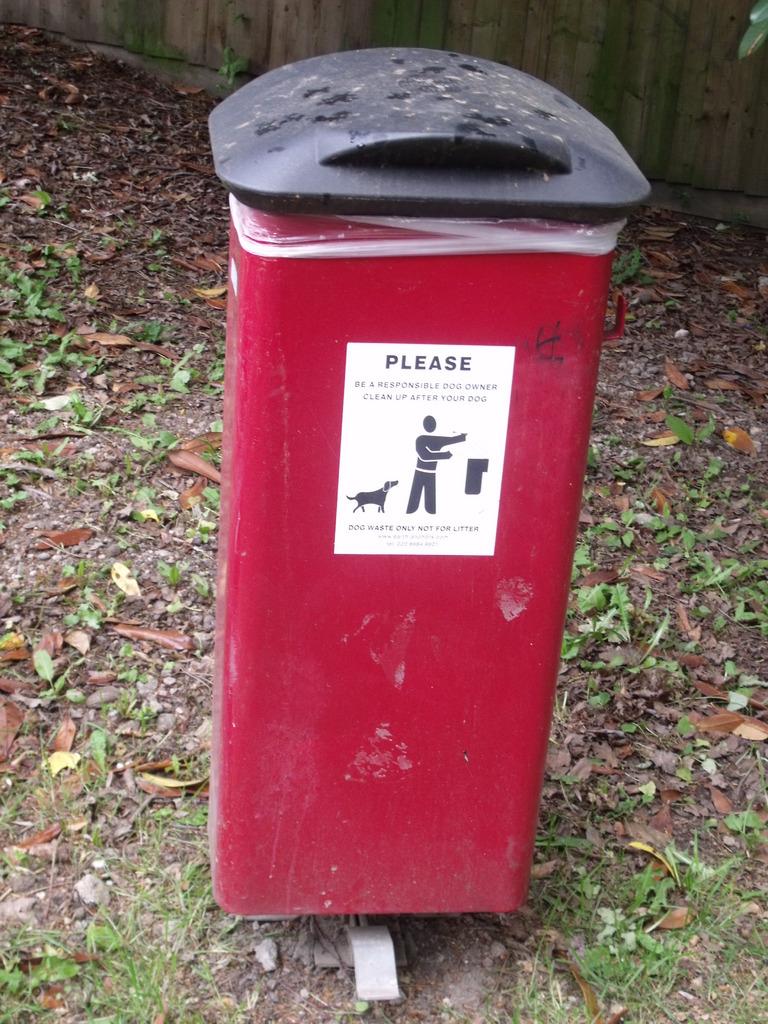What is instructed on the sign?
Give a very brief answer. Clean up after your dog. 